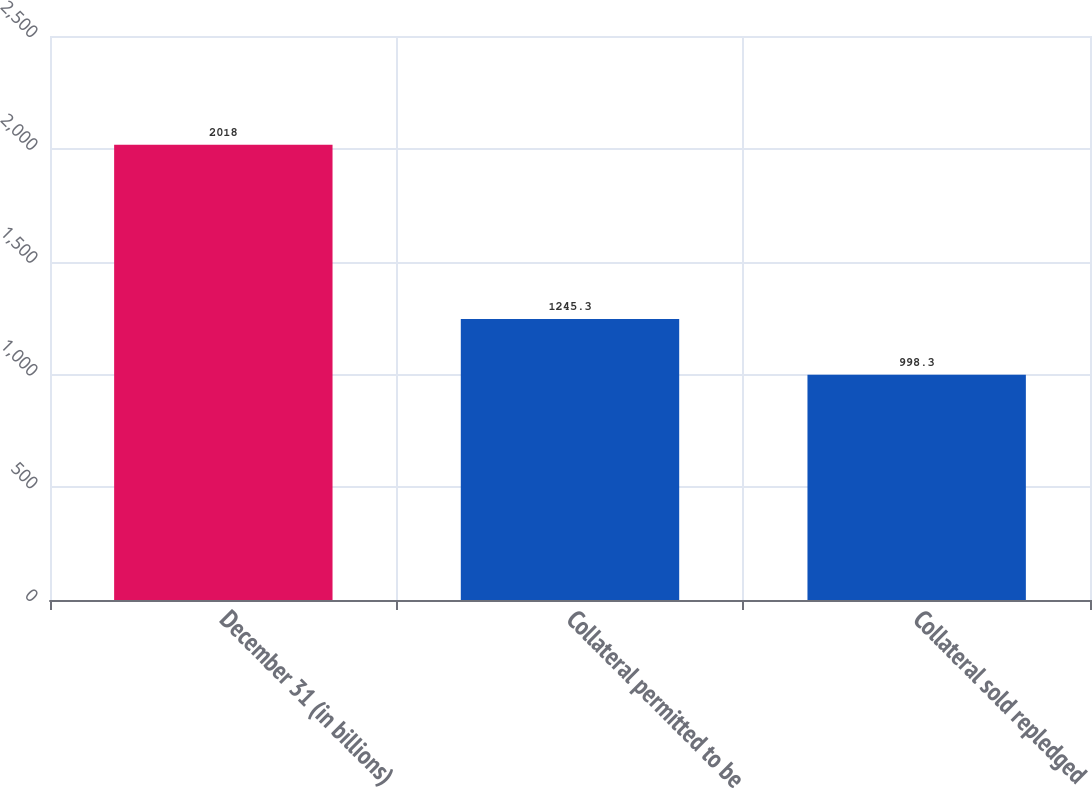Convert chart to OTSL. <chart><loc_0><loc_0><loc_500><loc_500><bar_chart><fcel>December 31 (in billions)<fcel>Collateral permitted to be<fcel>Collateral sold repledged<nl><fcel>2018<fcel>1245.3<fcel>998.3<nl></chart> 